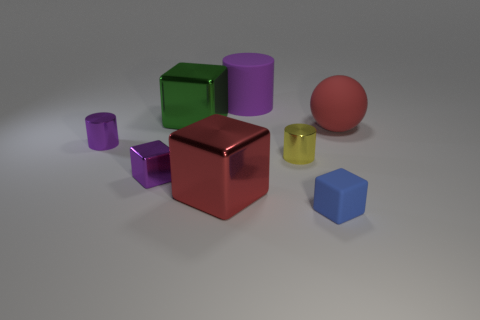How many purple objects are in front of the ball and behind the tiny metallic cube?
Offer a very short reply. 1. How many other things are there of the same size as the blue block?
Provide a short and direct response. 3. There is a matte thing in front of the small purple metallic cylinder; does it have the same shape as the red object behind the yellow shiny cylinder?
Make the answer very short. No. What number of things are large gray shiny spheres or large shiny blocks in front of the red rubber thing?
Provide a succinct answer. 1. What is the thing that is in front of the small shiny block and right of the purple matte thing made of?
Offer a very short reply. Rubber. Is there any other thing that is the same shape as the purple matte object?
Your response must be concise. Yes. The ball that is made of the same material as the big purple thing is what color?
Provide a short and direct response. Red. How many things are either spheres or blue blocks?
Make the answer very short. 2. There is a green metallic block; does it have the same size as the purple cylinder to the left of the large green shiny cube?
Make the answer very short. No. What color is the small rubber cube to the right of the metallic cylinder that is on the right side of the large shiny thing that is to the left of the red block?
Keep it short and to the point. Blue. 